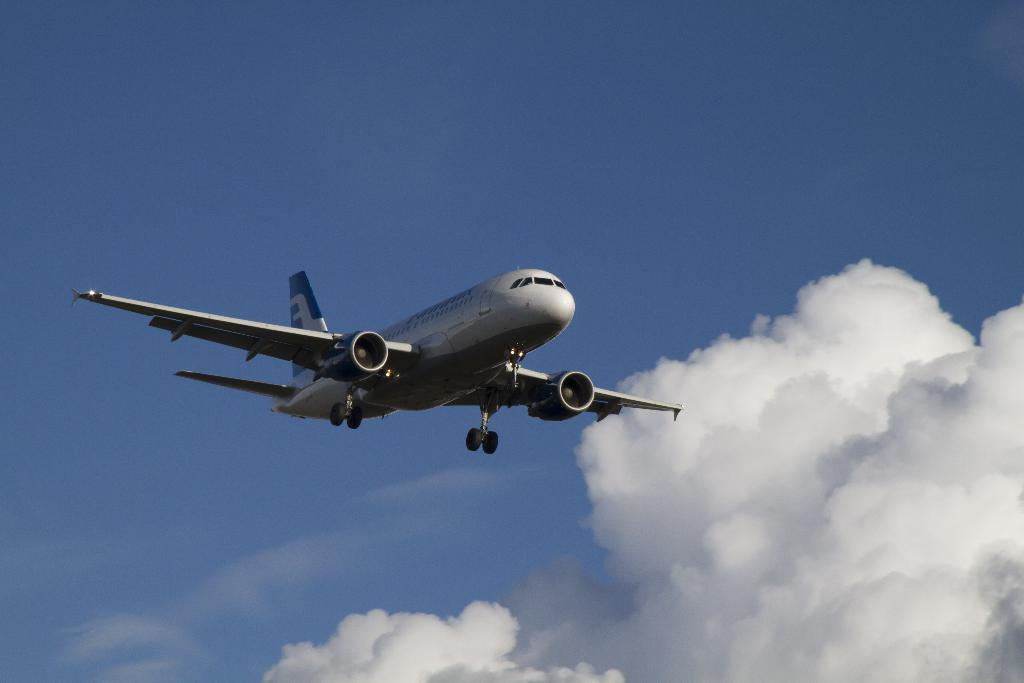What is the main subject of the image? The main subject of the image is an aircraft. What colors are used to paint the aircraft? The aircraft is blue and white in color. What is the aircraft doing in the image? The aircraft is flying in the air. What can be seen in the background of the image? The sky is visible in the background of the image. Can you tell me how many hydrants are visible near the aircraft in the image? There are no hydrants visible in the image; it only features an aircraft flying in the air. What type of bag is being carried by the aircraft in the image? There is no bag being carried by the aircraft in the image; it is simply flying in the air. 